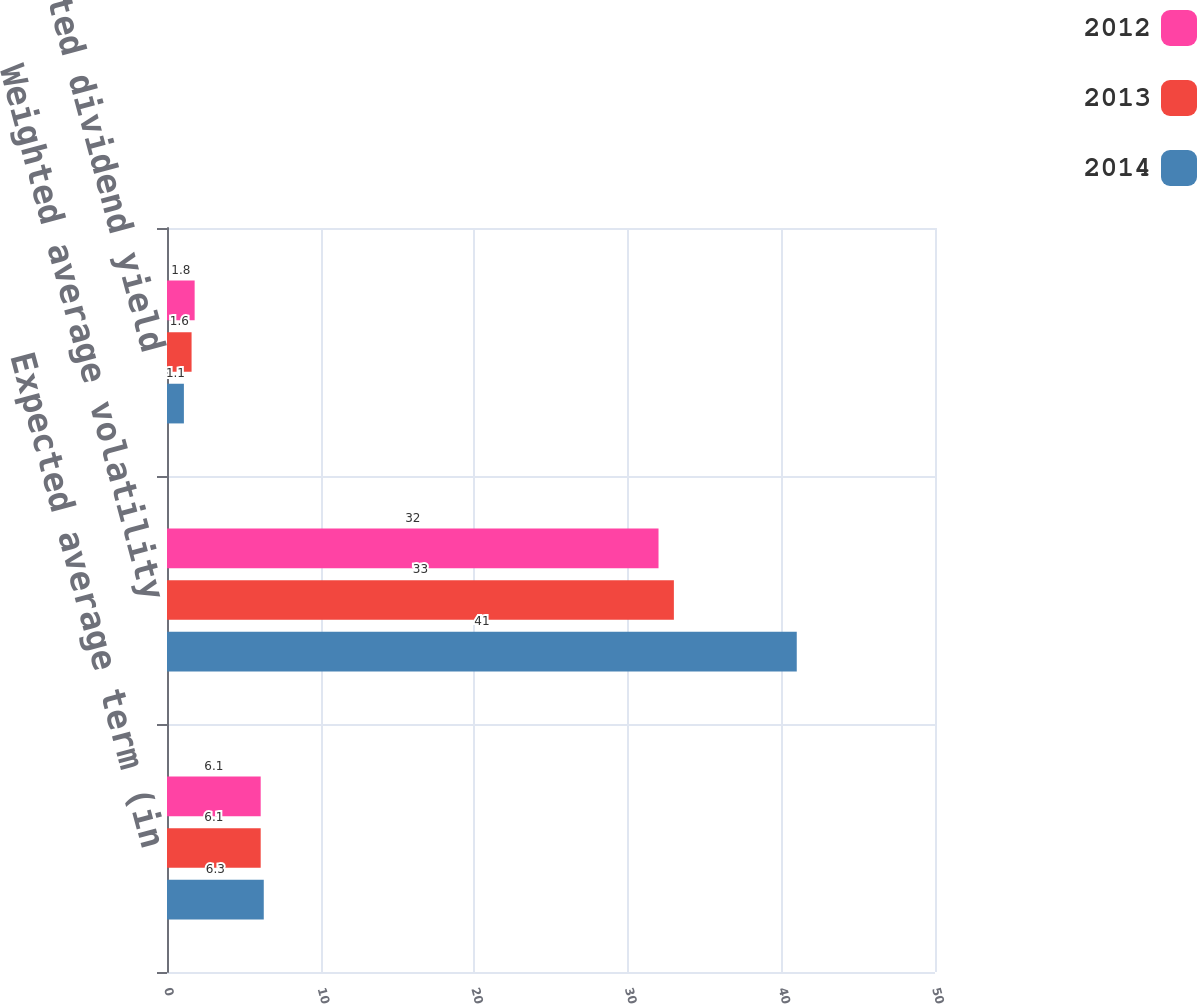Convert chart. <chart><loc_0><loc_0><loc_500><loc_500><stacked_bar_chart><ecel><fcel>Expected average term (in<fcel>Weighted average volatility<fcel>Expected dividend yield<nl><fcel>2012<fcel>6.1<fcel>32<fcel>1.8<nl><fcel>2013<fcel>6.1<fcel>33<fcel>1.6<nl><fcel>2014<fcel>6.3<fcel>41<fcel>1.1<nl></chart> 